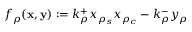Convert formula to latex. <formula><loc_0><loc_0><loc_500><loc_500>f _ { \rho } ( { x } , { y } ) \colon = k _ { \rho } ^ { + } x _ { \rho _ { s } } x _ { \rho _ { c } } - k _ { \rho } ^ { - } y _ { \rho }</formula> 